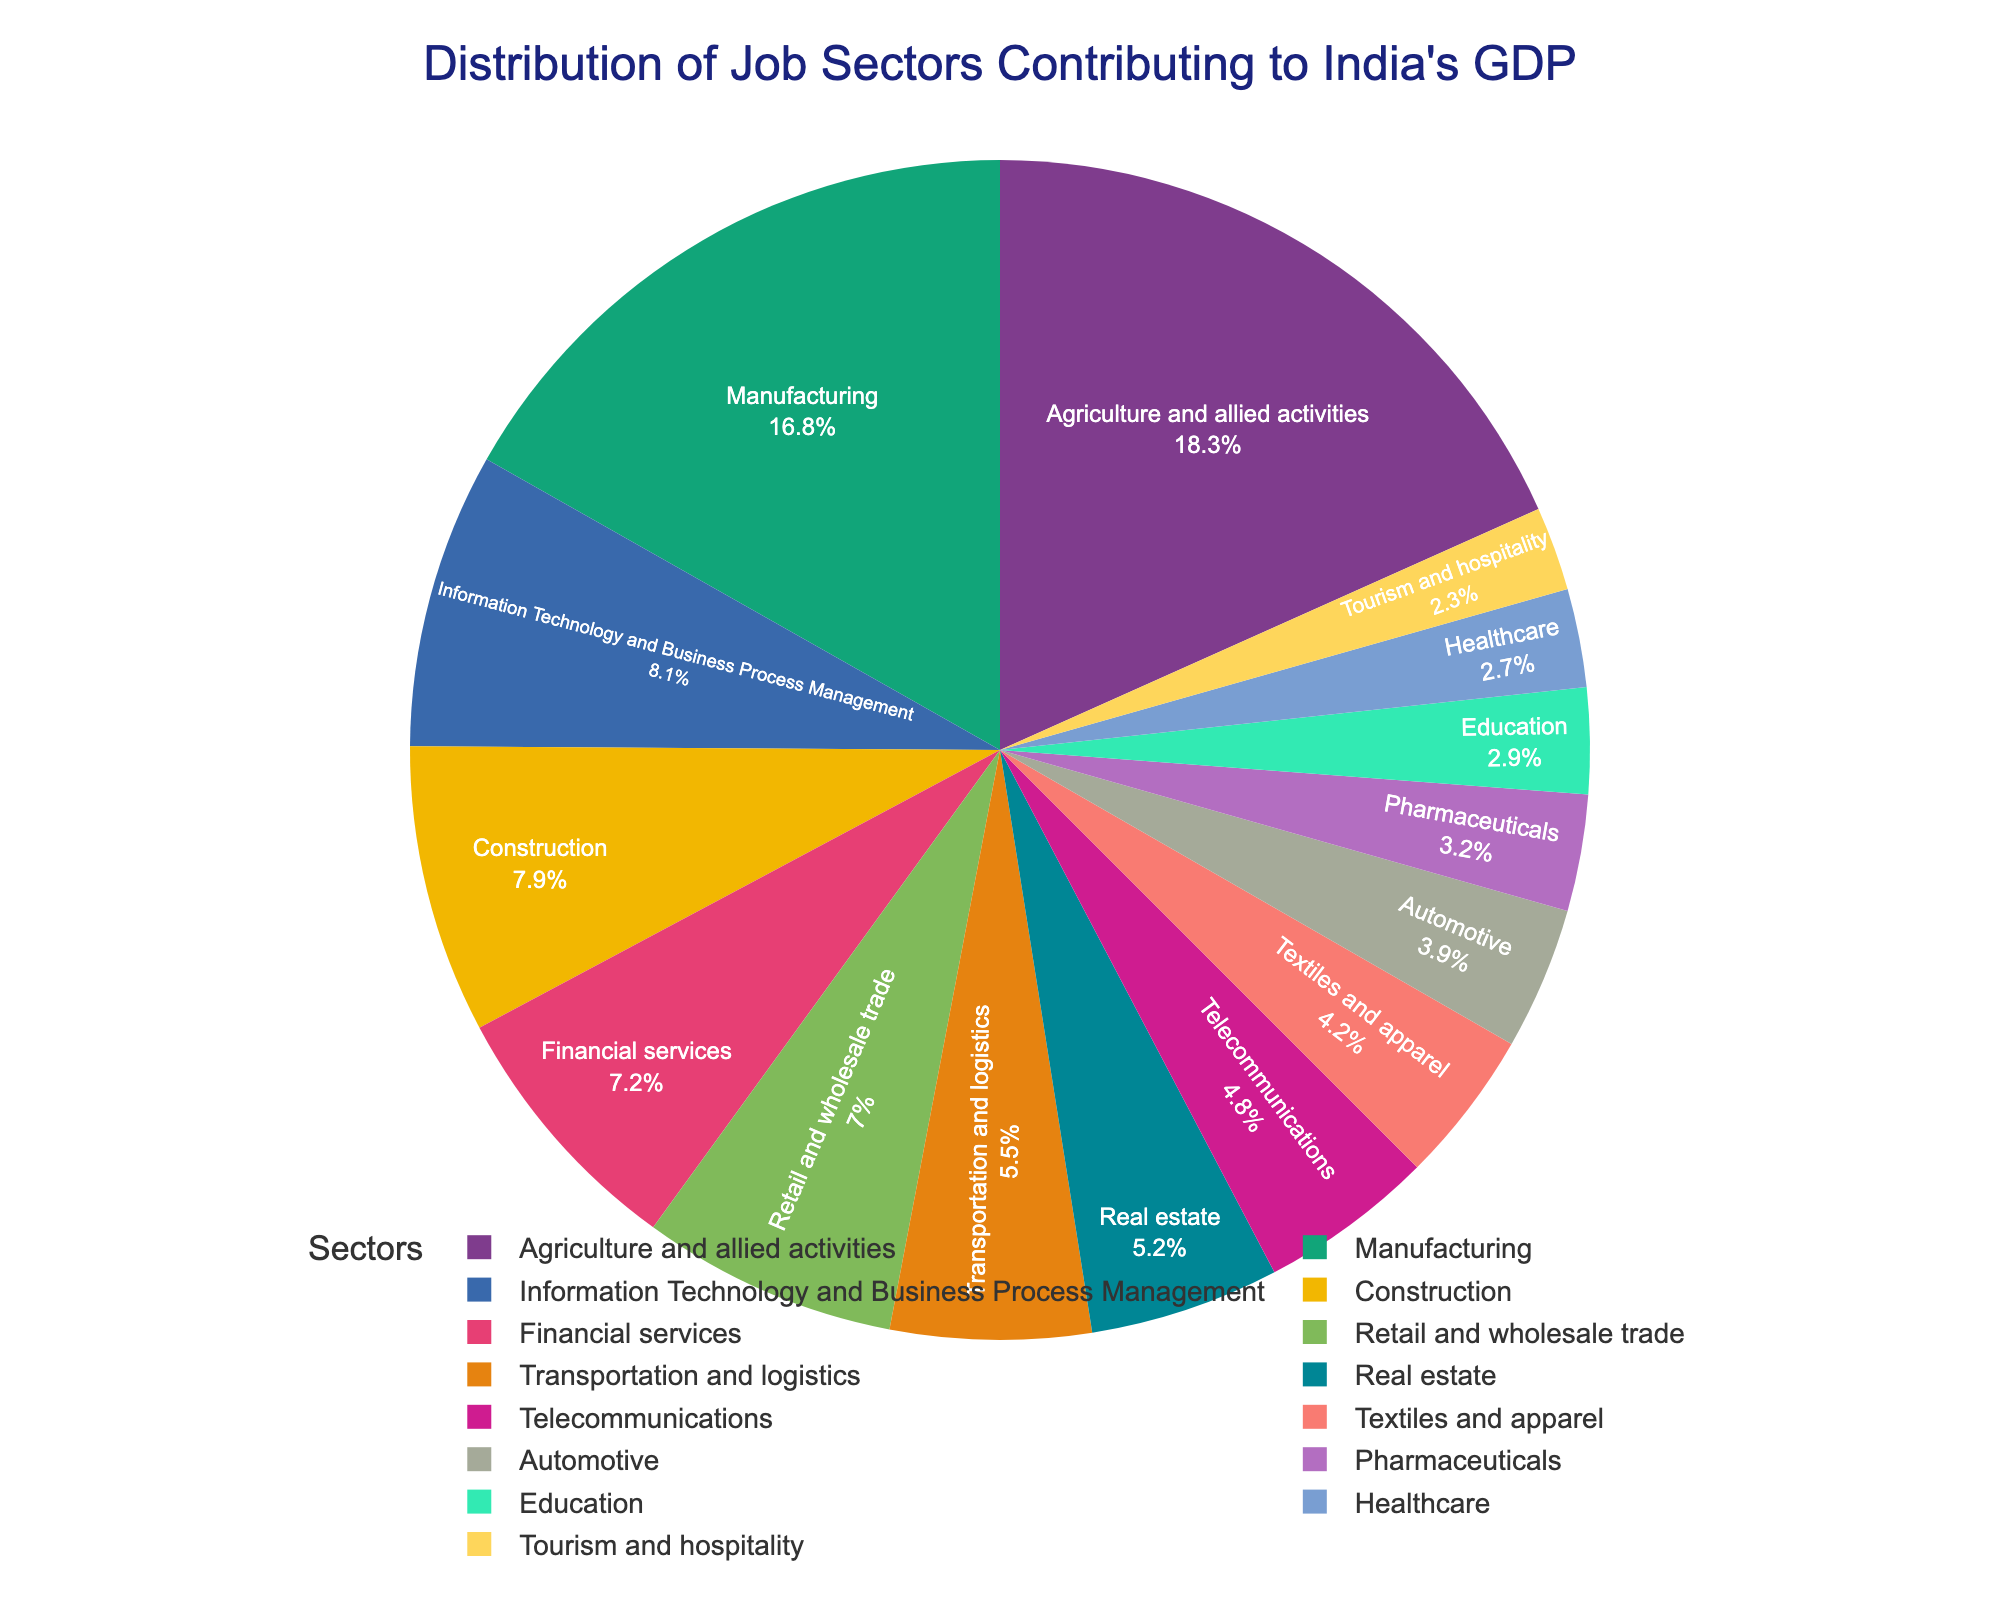What percentage of India's GDP is contributed by traditional industries such as Agriculture and Manufacturing combined? First, identify the percentage contribution of Agriculture and allied activities (18.3%) and Manufacturing (16.8%). Then, sum these two values: 18.3 + 16.8 = 35.1.
Answer: 35.1% Which sector contributes more to India's GDP: Telecommunications or Pharmaceuticals? Compare the percentages of the Telecommunications sector (4.8%) and the Pharmaceuticals sector (3.2%). Since 4.8% is greater than 3.2%, Telecommunications contributes more.
Answer: Telecommunications What is the total contribution of the Real Estate, Financial services, and Construction sectors? Identify the percentage contributions: Real Estate (5.2%), Financial services (7.2%), and Construction (7.9%). Sum these values: 5.2 + 7.2 + 7.9 = 20.3.
Answer: 20.3% How does Retail and Wholesale trade’s contribution compare with that of the Healthcare sector? Look at the percentages for both sectors: Retail and wholesale trade (7.0%) and Healthcare (2.7%). Since 7.0% is greater than 2.7%, Retail and Wholesale trade contributes more to India's GDP than Healthcare.
Answer: Retail and Wholesale trade Which are the top three sectors contributing to India's GDP, and their combined percentage? Identify the top three sectors by their percentages: Agriculture and allied activities (18.3%), Manufacturing (16.8%), and Information Technology and Business Process Management (8.1%). Sum these values: 18.3 + 16.8 + 8.1 = 43.2.
Answer: Agriculture and allied activities, Manufacturing, Information Technology and Business Process Management, 43.2% Is the contribution of Education higher or lower than that of the Tourism and Hospitality sector? Compare the percentages of the Education sector (2.9%) and Tourism and Hospitality sector (2.3%). Since 2.9% is greater than 2.3%, Education has a higher contribution.
Answer: Higher What is the difference in GDP contribution between the Automotive sector and the Textiles and Apparel sector? Identify the contributions from the Automotive sector (3.9%) and the Textiles and Apparel sector (4.2%), then subtract the smaller percentage from the larger one: 4.2 - 3.9 = 0.3.
Answer: 0.3% Among traditional industries like Agriculture, Manufacturing, and Construction, which has the smallest contribution to India's GDP? Compare the percentages of Agriculture and allied activities (18.3%), Manufacturing (16.8%), and Construction (7.9%). Construction has the smallest contribution.
Answer: Construction 